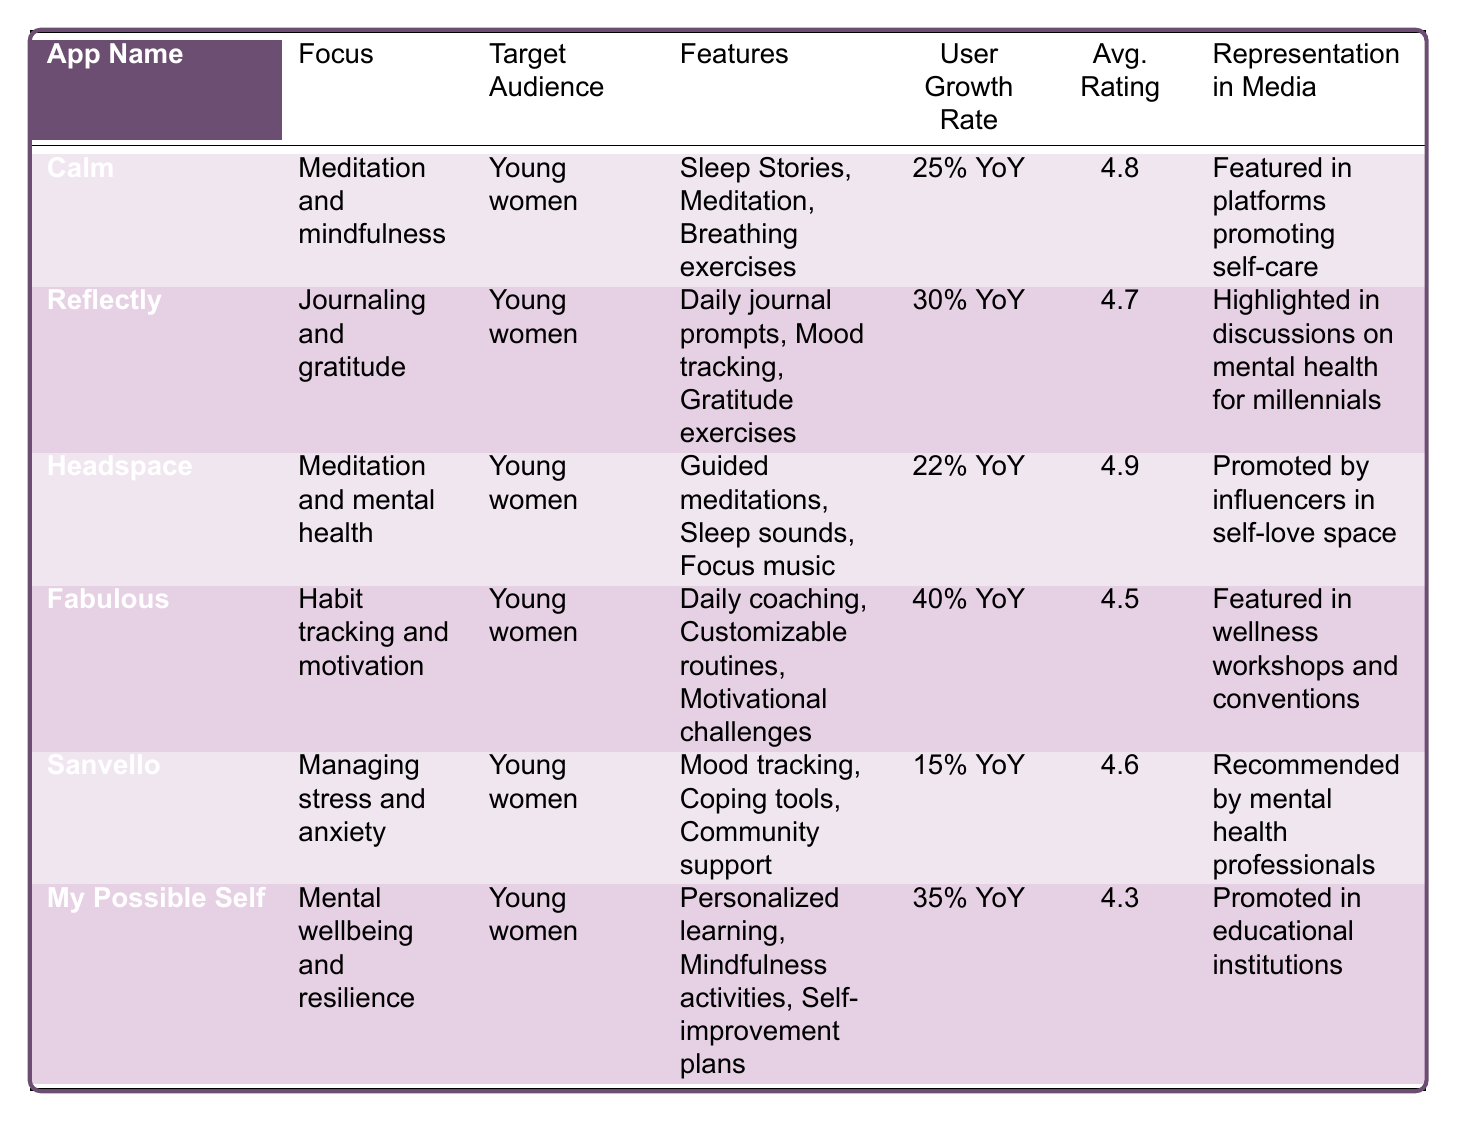What's the app with the highest average rating? The table shows average ratings for each app. The highest rating among them is for "Headspace" with an average rating of 4.9.
Answer: Headspace Which app has the lowest user growth rate? Comparing the user growth rates across the apps, "Sanvello" has the lowest at 15% year over year.
Answer: Sanvello How many apps focus on meditation and mindfulness? There are three apps that focus on meditation and mindfulness: "Calm," "Headspace," and "Fabulous."
Answer: Three What is the user growth rate difference between "Fabulous" and "Sanvello"? The user growth rate for "Fabulous" is 40% while "Sanvello" is 15%. The difference is 40% - 15% = 25%.
Answer: 25% Which app targets young women and includes community support in its features? "Sanvello" targets young women and includes community support as one of its features.
Answer: Sanvello Is there an app specifically focused on journaling and gratitude? Yes, "Reflectly" is specifically focused on journaling and gratitude.
Answer: Yes What is the average rating of apps that focus on meditation? The average ratings for the meditation-focused apps ("Calm" - 4.8, "Headspace" - 4.9) sum to 9.7. Dividing by 2 gives an average of 4.85.
Answer: 4.85 Which app has a focus on habit tracking and motivation? "Fabulous" focuses on habit tracking and motivation.
Answer: Fabulous How many apps are featured in media promoting self-care? From the table, "Calm" is featured in platforms promoting self-care. Therefore, there is 1 app that fits this description.
Answer: 1 What is the relationship between average rating and user growth rate for the app "My Possible Self"? "My Possible Self" has an average rating of 4.3 and a user growth rate of 35% YoY, indicating a positive correlation.
Answer: Positive correlation 